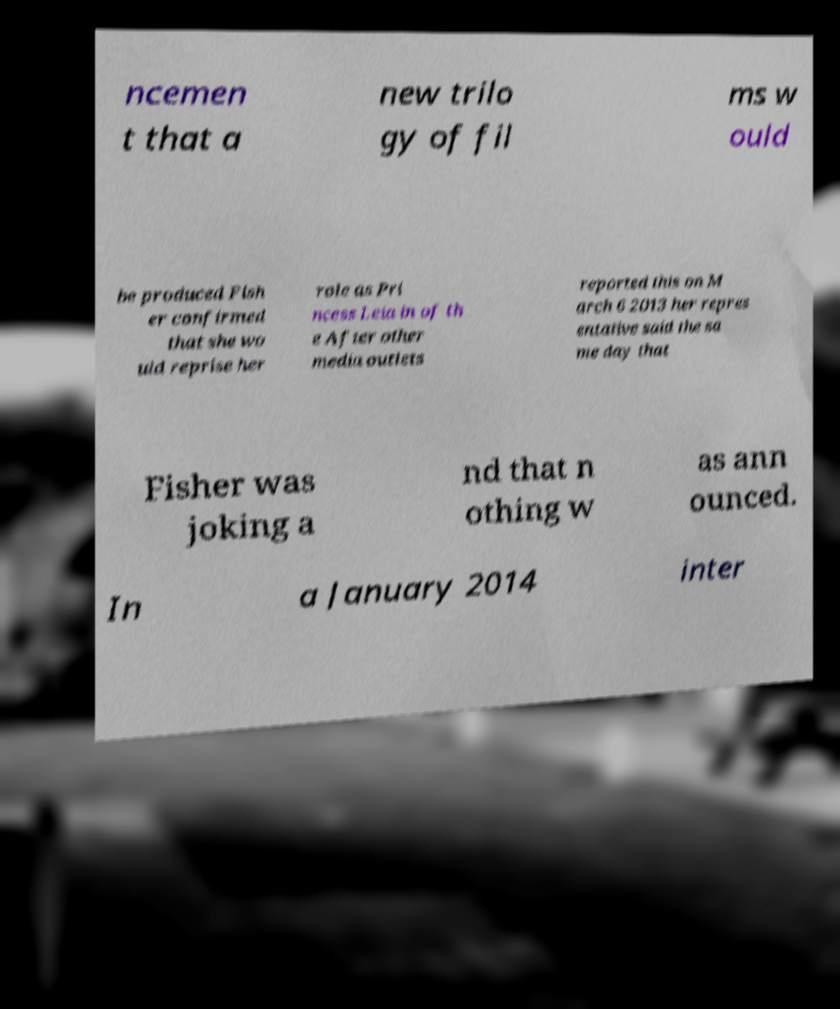For documentation purposes, I need the text within this image transcribed. Could you provide that? ncemen t that a new trilo gy of fil ms w ould be produced Fish er confirmed that she wo uld reprise her role as Pri ncess Leia in of th e After other media outlets reported this on M arch 6 2013 her repres entative said the sa me day that Fisher was joking a nd that n othing w as ann ounced. In a January 2014 inter 